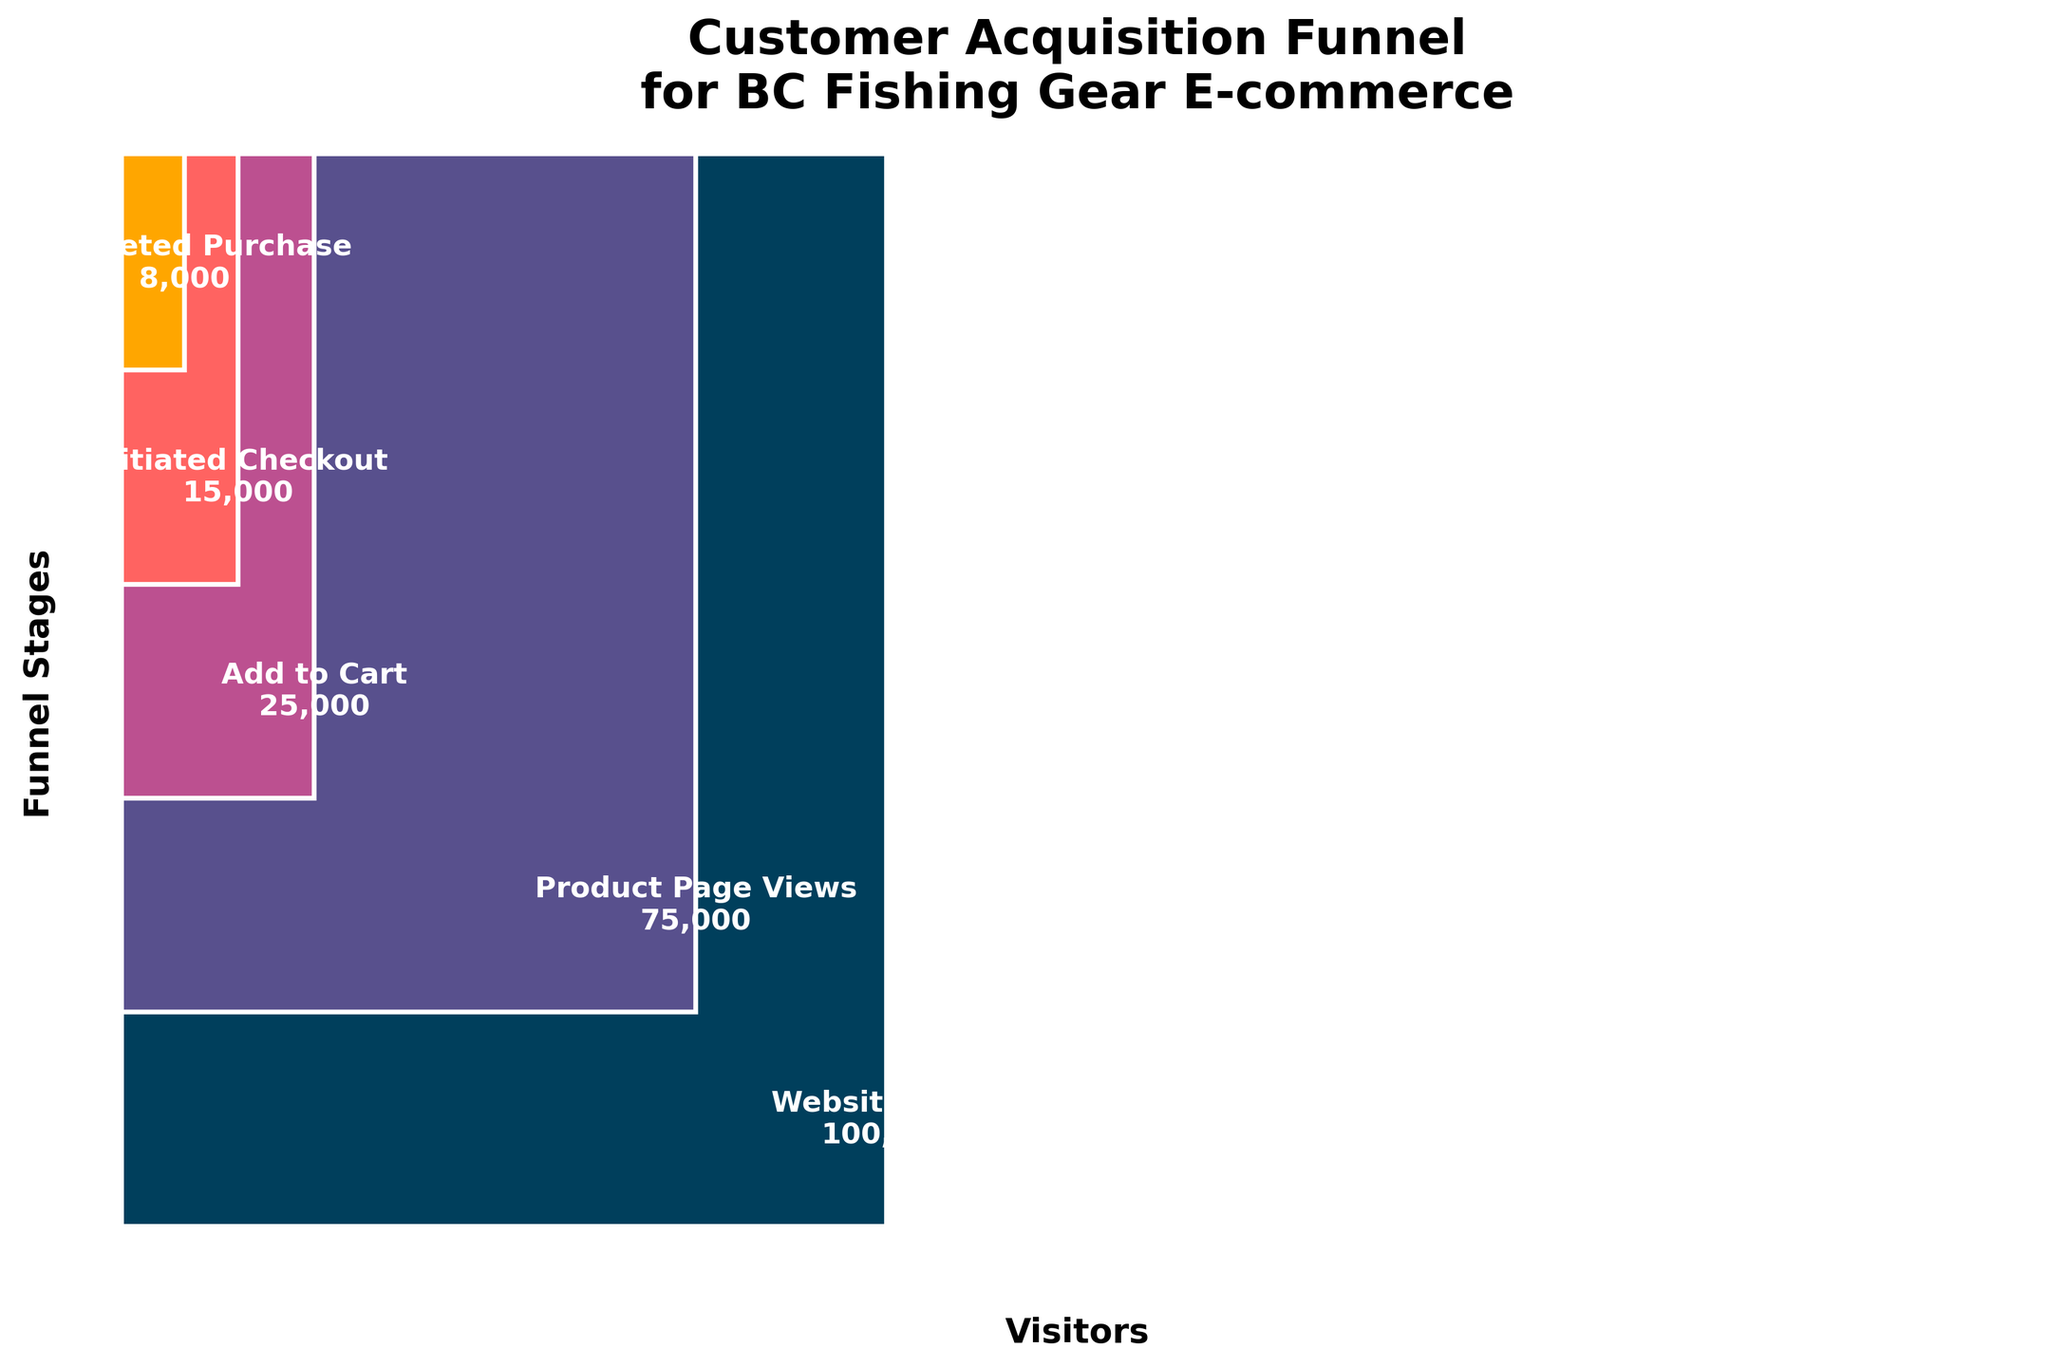What's the title of the figure? The title of the figure is often found at the top and provides an overview of the content being visualized. By looking at the top of the figure, we can see the title "Customer Acquisition Funnel for BC Fishing Gear E-commerce".
Answer: Customer Acquisition Funnel for BC Fishing Gear E-commerce What is the color of the bar representing 'Website Visits'? Colors can be identified visually, and the color of the bar representing 'Website Visits' is the first one at the bottom. It is a dark blue shade.
Answer: Dark blue How many stages are represented in the funnel chart? We can count the distinct stages listed along the funnel from top to bottom. The stages are 'Website Visits', 'Product Page Views', 'Add to Cart', 'Initiated Checkout', 'Completed Purchase'. There are 5 stages in total.
Answer: 5 Which stage has the fewest visitors? By looking at the height and the visitor number labels on the bars, we can see that 'Completed Purchase' has the fewest visitors at 8,000.
Answer: Completed Purchase How many visitors reach the 'Add to Cart' stage? The number of visitors is indicated within the bar representing 'Add to Cart'. Referring to this label, 'Add to Cart' has 25,000 visitors.
Answer: 25,000 What is the difference in visitor numbers between 'Product Page Views' and 'Completed Purchase'? 'Product Page Views' has 75,000 visitors and 'Completed Purchase' has 8,000 visitors. Subtracting these gives the difference: 75,000 - 8,000 = 67,000.
Answer: 67,000 How many visitors drop off between the 'Initiated Checkout' and 'Completed Purchase' stages? 'Initiated Checkout' has 15,000 visitors and 'Completed Purchase' has 8,000 visitors. The drop-off is calculated as 15,000 - 8,000 = 7,000.
Answer: 7,000 What percentage of 'Website Visits' proceeds to 'Completed Purchase'? To find the percentage, divide the number of 'Completed Purchase' visitors by the number of 'Website Visits' and multiply by 100. Thus, (8,000 / 100,000) * 100 = 8%.
Answer: 8% Which stage has just under half the visitors of 'Product Page Views'? We need to find a stage with visitors close to half of 75,000 ('Product Page Views'). Half of 75,000 is 37,500, and 'Add to Cart' with 25,000 visitors is close but just under half.
Answer: Add to Cart What stage directly follows 'Product Page Views' in the funnel? The funnel is read top to bottom; right after 'Product Page Views' comes 'Add to Cart'.
Answer: Add to Cart 